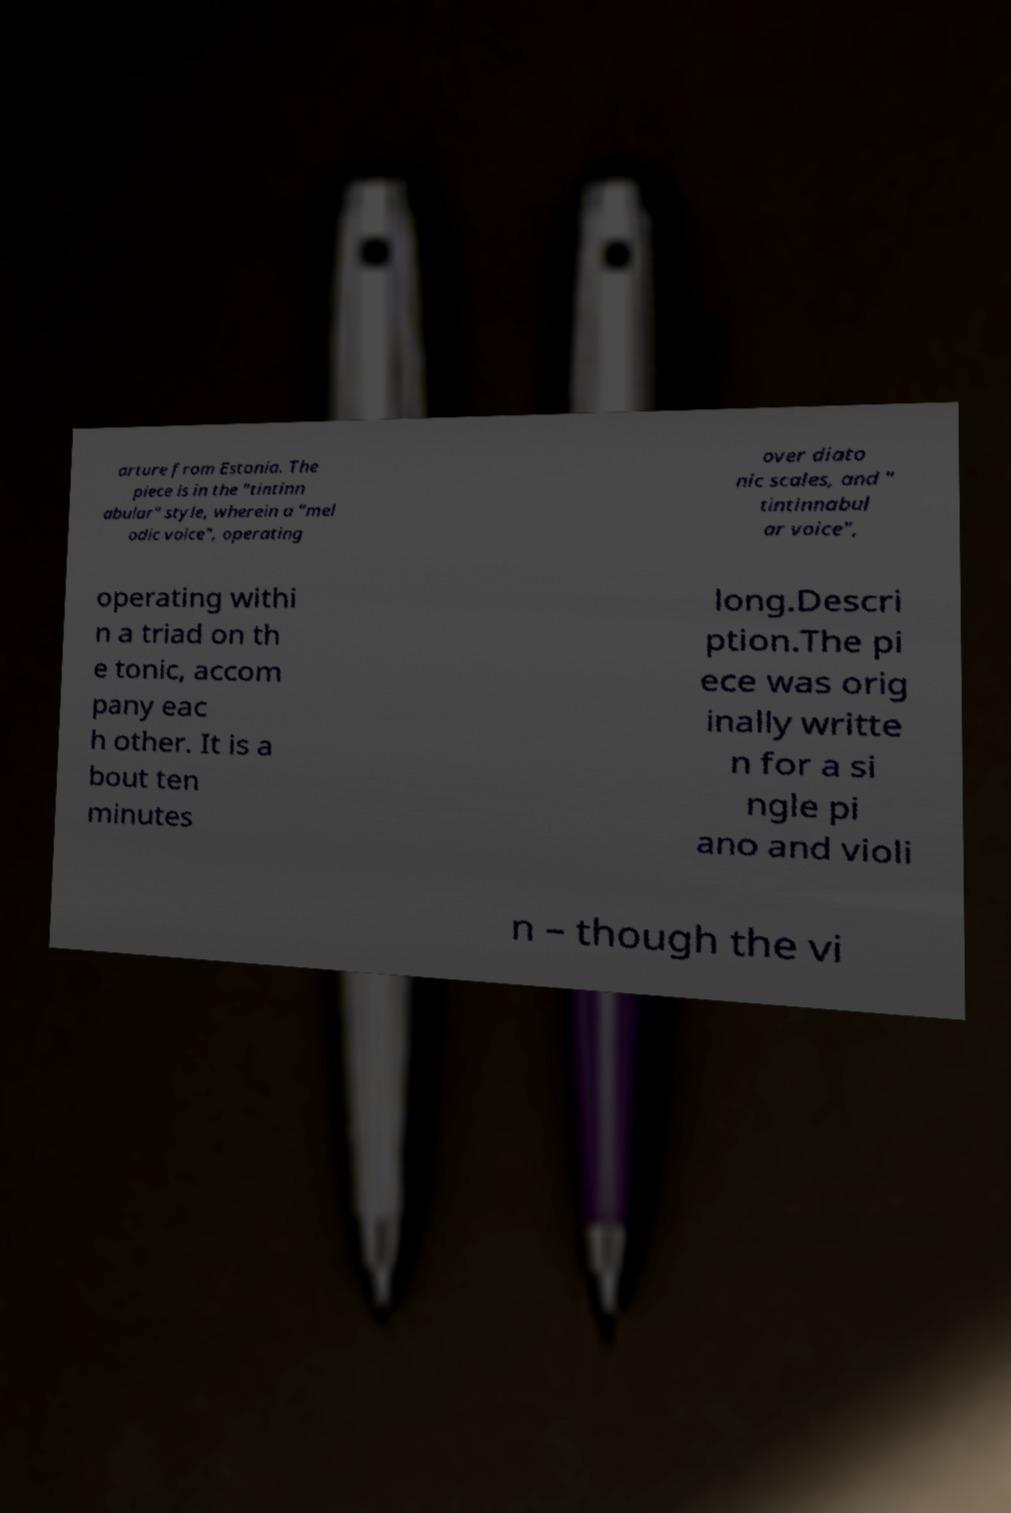Please read and relay the text visible in this image. What does it say? arture from Estonia. The piece is in the "tintinn abular" style, wherein a "mel odic voice", operating over diato nic scales, and " tintinnabul ar voice", operating withi n a triad on th e tonic, accom pany eac h other. It is a bout ten minutes long.Descri ption.The pi ece was orig inally writte n for a si ngle pi ano and violi n – though the vi 